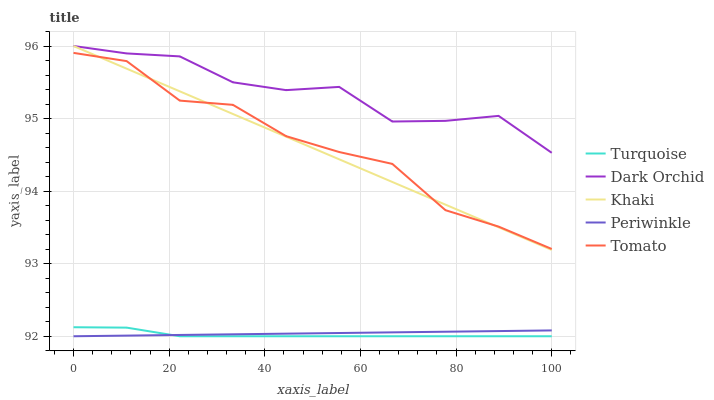Does Turquoise have the minimum area under the curve?
Answer yes or no. Yes. Does Dark Orchid have the maximum area under the curve?
Answer yes or no. Yes. Does Khaki have the minimum area under the curve?
Answer yes or no. No. Does Khaki have the maximum area under the curve?
Answer yes or no. No. Is Khaki the smoothest?
Answer yes or no. Yes. Is Tomato the roughest?
Answer yes or no. Yes. Is Turquoise the smoothest?
Answer yes or no. No. Is Turquoise the roughest?
Answer yes or no. No. Does Turquoise have the lowest value?
Answer yes or no. Yes. Does Khaki have the lowest value?
Answer yes or no. No. Does Dark Orchid have the highest value?
Answer yes or no. Yes. Does Turquoise have the highest value?
Answer yes or no. No. Is Turquoise less than Tomato?
Answer yes or no. Yes. Is Khaki greater than Turquoise?
Answer yes or no. Yes. Does Turquoise intersect Periwinkle?
Answer yes or no. Yes. Is Turquoise less than Periwinkle?
Answer yes or no. No. Is Turquoise greater than Periwinkle?
Answer yes or no. No. Does Turquoise intersect Tomato?
Answer yes or no. No. 